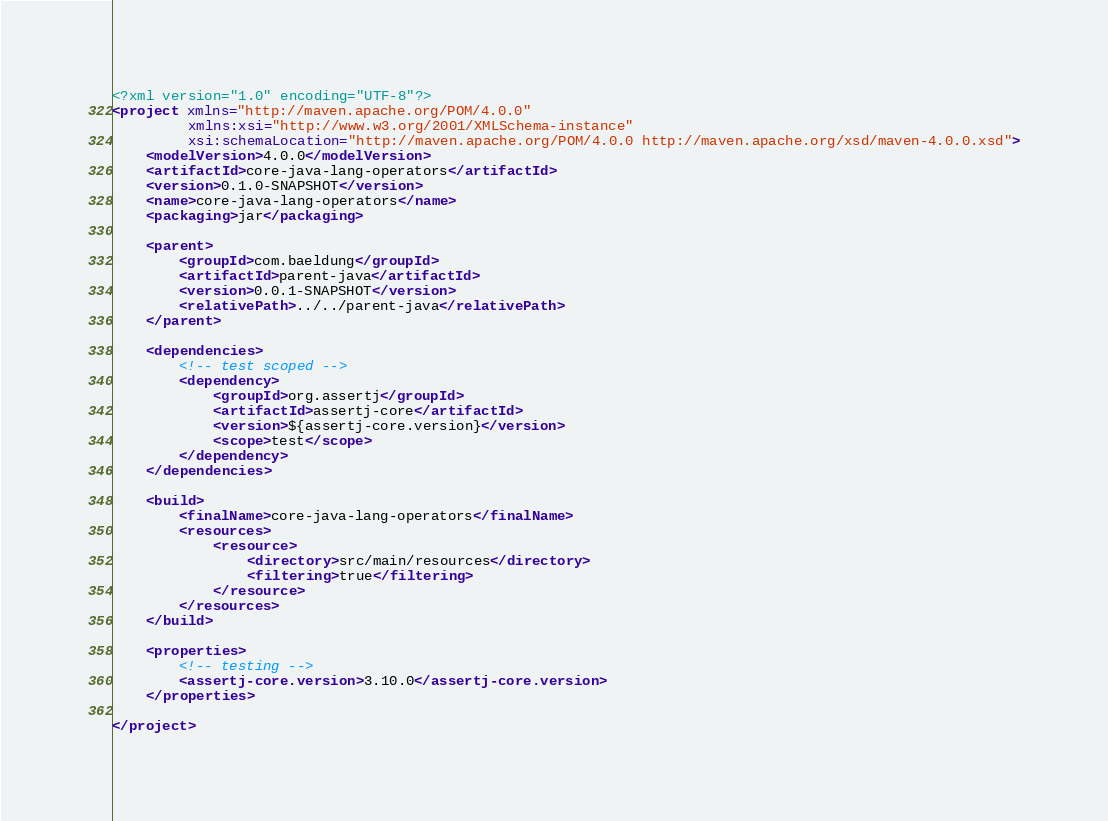<code> <loc_0><loc_0><loc_500><loc_500><_XML_><?xml version="1.0" encoding="UTF-8"?>
<project xmlns="http://maven.apache.org/POM/4.0.0"
         xmlns:xsi="http://www.w3.org/2001/XMLSchema-instance"
         xsi:schemaLocation="http://maven.apache.org/POM/4.0.0 http://maven.apache.org/xsd/maven-4.0.0.xsd">
    <modelVersion>4.0.0</modelVersion>
    <artifactId>core-java-lang-operators</artifactId>
    <version>0.1.0-SNAPSHOT</version>
    <name>core-java-lang-operators</name>
    <packaging>jar</packaging>

    <parent>
        <groupId>com.baeldung</groupId>
        <artifactId>parent-java</artifactId>
        <version>0.0.1-SNAPSHOT</version>
        <relativePath>../../parent-java</relativePath>
    </parent>

    <dependencies>
        <!-- test scoped -->
        <dependency>
            <groupId>org.assertj</groupId>
            <artifactId>assertj-core</artifactId>
            <version>${assertj-core.version}</version>
            <scope>test</scope>
        </dependency>
    </dependencies>

    <build>
        <finalName>core-java-lang-operators</finalName>
        <resources>
            <resource>
                <directory>src/main/resources</directory>
                <filtering>true</filtering>
            </resource>
        </resources>
    </build>

    <properties>
        <!-- testing -->
        <assertj-core.version>3.10.0</assertj-core.version>
    </properties>

</project>
</code> 